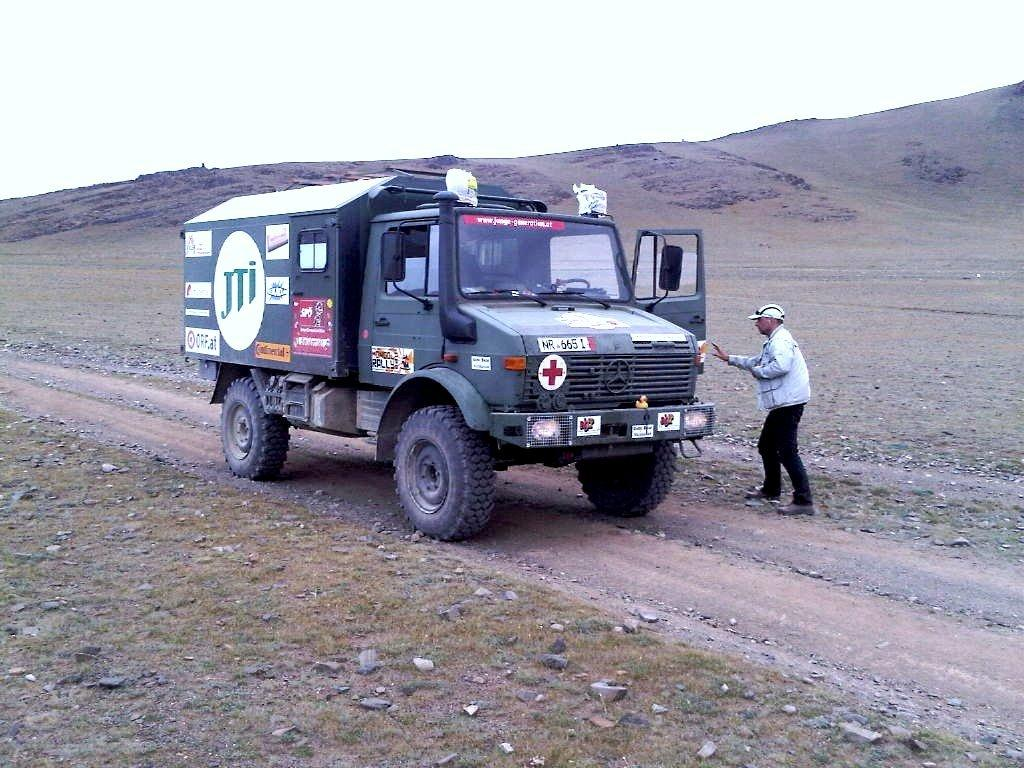Who or what is present in the image? There is a person in the image. What type of vehicle can be seen in the image? There is a truck in the image. What is the ground made of in the image? Grass and stones are visible at the bottom of the image. What can be seen in the distance in the image? The sky is visible in the background of the image. What type of range can be seen in the image? There is no range present in the image. How does the person in the image wash their hands? The image does not show the person washing their hands, so it cannot be determined from the image. 